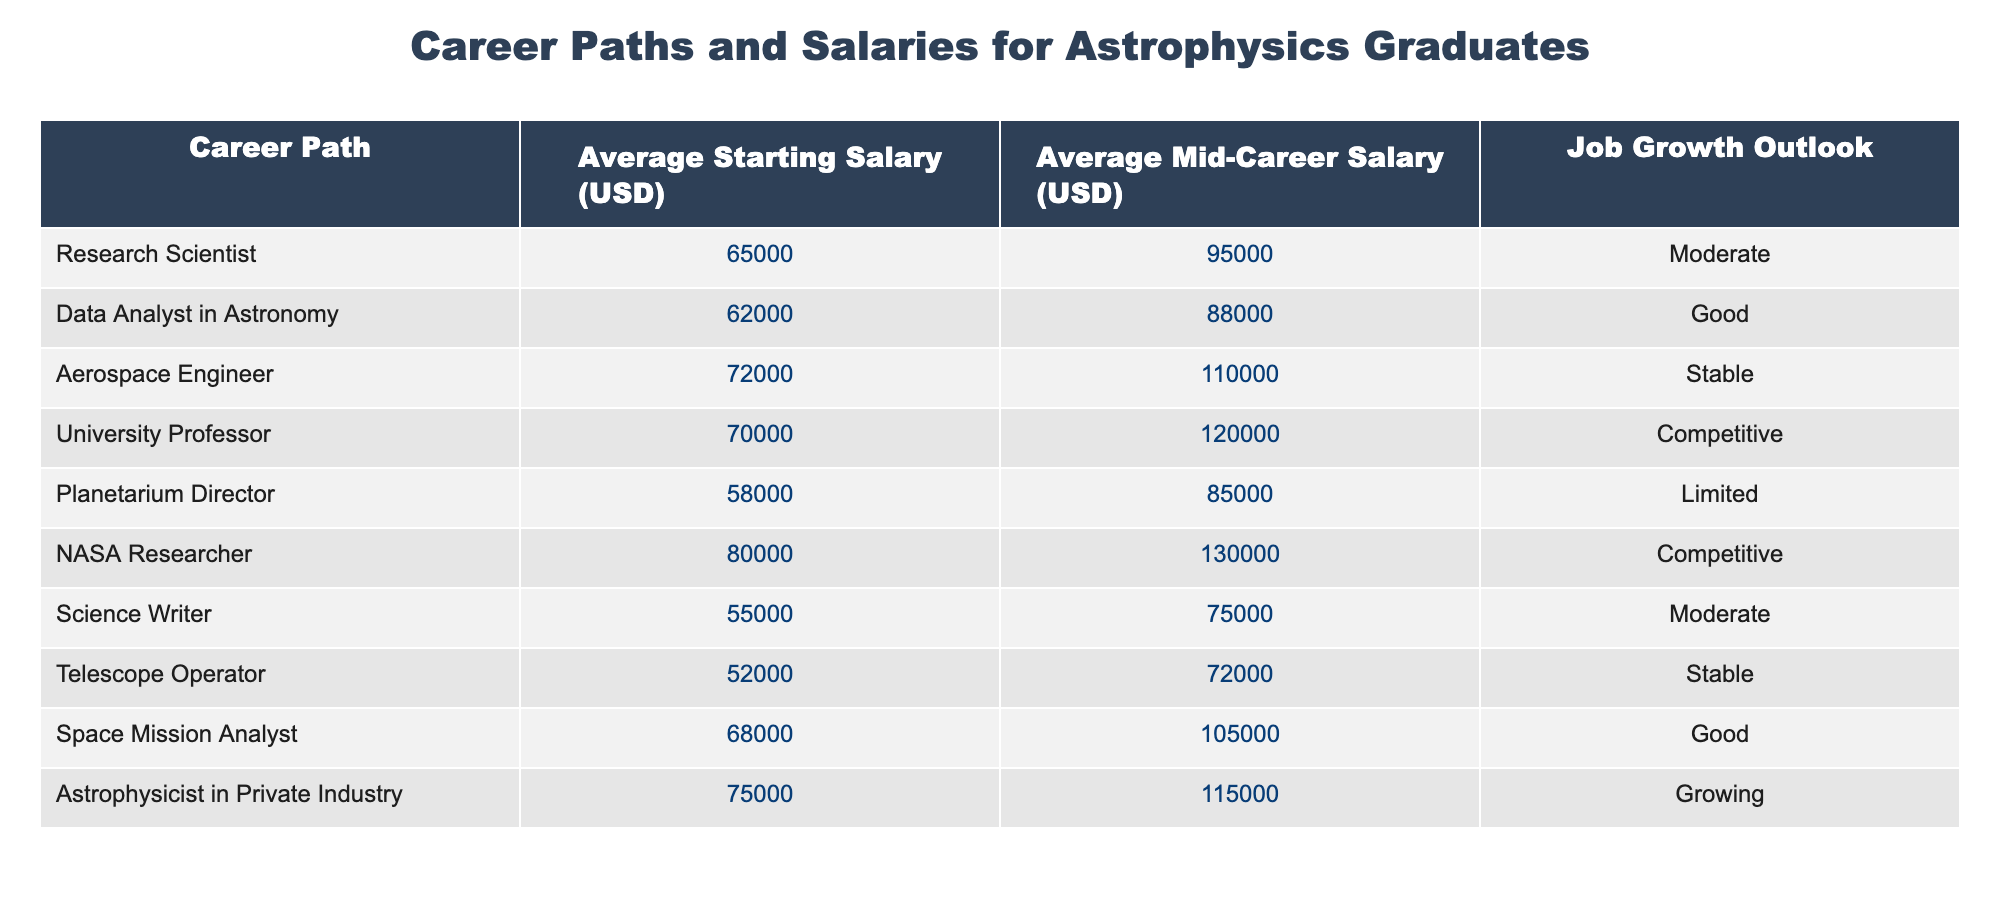What is the average starting salary for a NASA Researcher? The table provides a specific value for NASA Researcher's average starting salary, which is directly listed under the "Average Starting Salary (USD)" column. Referring to the row for NASA Researcher, the value is 80000 USD.
Answer: 80000 Which career path has the highest average mid-career salary? The table presents average mid-career salaries for each career path. By comparing all listed mid-career salaries, NASA Researcher has the highest average mid-career salary at 130000 USD.
Answer: NASA Researcher Is the job growth outlook for University Professor competitive? The table states the job growth outlook for University Professor under the "Job Growth Outlook" column. The value listed is "Competitive," confirming that the outlook is indeed competitive.
Answer: Yes What is the difference between the average mid-career salary of an Aerospace Engineer and a Data Analyst in Astronomy? To find the difference, first, identify the average mid-career salary for each: Aerospace Engineer is 110000 USD and Data Analyst in Astronomy is 88000 USD. The difference is 110000 - 88000 = 22000 USD.
Answer: 22000 How many career paths listed have an average starting salary above 60000 USD? By examining the "Average Starting Salary (USD)" column, the career paths with salaries above 60000 USD are: Research Scientist, Aerospace Engineer, University Professor, NASA Researcher, and Astrophysicist in Private Industry. There are 5 such paths.
Answer: 5 What is the average starting salary for all listed careers? To calculate the average starting salary, sum all starting salaries: 65000 + 62000 + 72000 + 70000 + 58000 + 80000 + 55000 + 52000 + 68000 + 75000 = 663000 USD. Next, divide by the number of career paths (10): 663000 / 10 = 66300 USD.
Answer: 66300 Does the Planetarium Director role have a better job growth outlook than the Telescope Operator? Looking at the "Job Growth Outlook" column, Planetarium Director has "Limited" whereas Telescope Operator has "Stable." Since "Stable" is better than "Limited," the statement is false.
Answer: No What is the range of average starting salaries in the table? The highest average starting salary is for NASA Researcher at 80000 USD, and the lowest is for Telescope Operator at 52000 USD. The range is calculated as 80000 - 52000 = 28000 USD.
Answer: 28000 